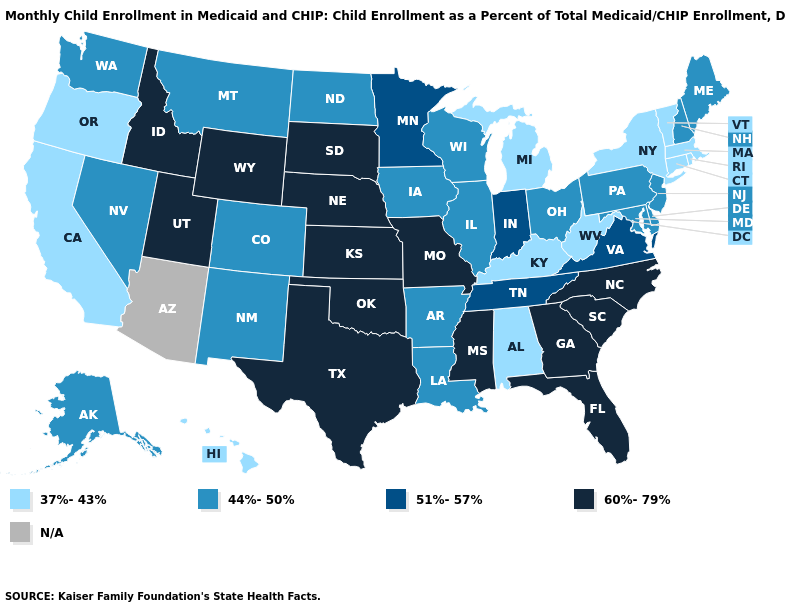What is the value of North Carolina?
Give a very brief answer. 60%-79%. Name the states that have a value in the range 60%-79%?
Short answer required. Florida, Georgia, Idaho, Kansas, Mississippi, Missouri, Nebraska, North Carolina, Oklahoma, South Carolina, South Dakota, Texas, Utah, Wyoming. What is the value of Minnesota?
Short answer required. 51%-57%. Which states have the lowest value in the USA?
Short answer required. Alabama, California, Connecticut, Hawaii, Kentucky, Massachusetts, Michigan, New York, Oregon, Rhode Island, Vermont, West Virginia. Among the states that border California , does Oregon have the lowest value?
Write a very short answer. Yes. What is the lowest value in the South?
Short answer required. 37%-43%. What is the value of Arizona?
Answer briefly. N/A. What is the highest value in states that border Utah?
Keep it brief. 60%-79%. What is the value of Montana?
Concise answer only. 44%-50%. Among the states that border Louisiana , does Texas have the highest value?
Write a very short answer. Yes. Does Oregon have the highest value in the West?
Concise answer only. No. Name the states that have a value in the range N/A?
Give a very brief answer. Arizona. Which states have the lowest value in the Northeast?
Short answer required. Connecticut, Massachusetts, New York, Rhode Island, Vermont. Does Michigan have the lowest value in the MidWest?
Keep it brief. Yes. 